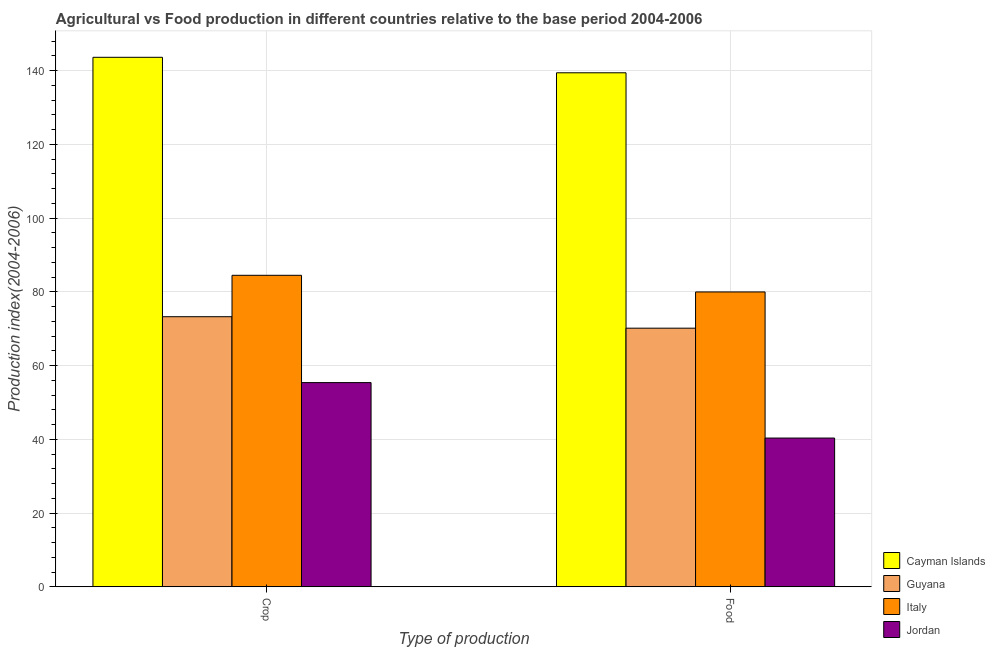How many groups of bars are there?
Ensure brevity in your answer.  2. Are the number of bars per tick equal to the number of legend labels?
Your answer should be compact. Yes. How many bars are there on the 2nd tick from the left?
Give a very brief answer. 4. What is the label of the 2nd group of bars from the left?
Give a very brief answer. Food. What is the food production index in Italy?
Ensure brevity in your answer.  79.96. Across all countries, what is the maximum food production index?
Your response must be concise. 139.4. Across all countries, what is the minimum crop production index?
Give a very brief answer. 55.37. In which country was the food production index maximum?
Your answer should be very brief. Cayman Islands. In which country was the food production index minimum?
Keep it short and to the point. Jordan. What is the total food production index in the graph?
Offer a terse response. 329.82. What is the difference between the food production index in Cayman Islands and that in Guyana?
Give a very brief answer. 69.27. What is the difference between the food production index in Italy and the crop production index in Jordan?
Provide a short and direct response. 24.59. What is the average crop production index per country?
Make the answer very short. 89.17. What is the difference between the food production index and crop production index in Guyana?
Offer a terse response. -3.11. In how many countries, is the food production index greater than 88 ?
Your response must be concise. 1. What is the ratio of the food production index in Italy to that in Cayman Islands?
Keep it short and to the point. 0.57. What does the 2nd bar from the left in Food represents?
Keep it short and to the point. Guyana. What does the 4th bar from the right in Crop represents?
Offer a very short reply. Cayman Islands. Are all the bars in the graph horizontal?
Your answer should be compact. No. Are the values on the major ticks of Y-axis written in scientific E-notation?
Provide a succinct answer. No. Does the graph contain any zero values?
Give a very brief answer. No. What is the title of the graph?
Your answer should be compact. Agricultural vs Food production in different countries relative to the base period 2004-2006. Does "Bahrain" appear as one of the legend labels in the graph?
Keep it short and to the point. No. What is the label or title of the X-axis?
Offer a very short reply. Type of production. What is the label or title of the Y-axis?
Make the answer very short. Production index(2004-2006). What is the Production index(2004-2006) of Cayman Islands in Crop?
Offer a very short reply. 143.6. What is the Production index(2004-2006) of Guyana in Crop?
Give a very brief answer. 73.24. What is the Production index(2004-2006) in Italy in Crop?
Provide a succinct answer. 84.47. What is the Production index(2004-2006) of Jordan in Crop?
Provide a short and direct response. 55.37. What is the Production index(2004-2006) of Cayman Islands in Food?
Provide a succinct answer. 139.4. What is the Production index(2004-2006) in Guyana in Food?
Offer a terse response. 70.13. What is the Production index(2004-2006) in Italy in Food?
Offer a very short reply. 79.96. What is the Production index(2004-2006) of Jordan in Food?
Give a very brief answer. 40.33. Across all Type of production, what is the maximum Production index(2004-2006) of Cayman Islands?
Give a very brief answer. 143.6. Across all Type of production, what is the maximum Production index(2004-2006) of Guyana?
Keep it short and to the point. 73.24. Across all Type of production, what is the maximum Production index(2004-2006) in Italy?
Offer a very short reply. 84.47. Across all Type of production, what is the maximum Production index(2004-2006) in Jordan?
Your response must be concise. 55.37. Across all Type of production, what is the minimum Production index(2004-2006) in Cayman Islands?
Offer a very short reply. 139.4. Across all Type of production, what is the minimum Production index(2004-2006) in Guyana?
Your response must be concise. 70.13. Across all Type of production, what is the minimum Production index(2004-2006) of Italy?
Make the answer very short. 79.96. Across all Type of production, what is the minimum Production index(2004-2006) of Jordan?
Your response must be concise. 40.33. What is the total Production index(2004-2006) in Cayman Islands in the graph?
Give a very brief answer. 283. What is the total Production index(2004-2006) of Guyana in the graph?
Keep it short and to the point. 143.37. What is the total Production index(2004-2006) in Italy in the graph?
Offer a terse response. 164.43. What is the total Production index(2004-2006) of Jordan in the graph?
Your answer should be very brief. 95.7. What is the difference between the Production index(2004-2006) in Guyana in Crop and that in Food?
Offer a very short reply. 3.11. What is the difference between the Production index(2004-2006) of Italy in Crop and that in Food?
Ensure brevity in your answer.  4.51. What is the difference between the Production index(2004-2006) of Jordan in Crop and that in Food?
Give a very brief answer. 15.04. What is the difference between the Production index(2004-2006) of Cayman Islands in Crop and the Production index(2004-2006) of Guyana in Food?
Offer a very short reply. 73.47. What is the difference between the Production index(2004-2006) in Cayman Islands in Crop and the Production index(2004-2006) in Italy in Food?
Your answer should be compact. 63.64. What is the difference between the Production index(2004-2006) of Cayman Islands in Crop and the Production index(2004-2006) of Jordan in Food?
Your answer should be very brief. 103.27. What is the difference between the Production index(2004-2006) in Guyana in Crop and the Production index(2004-2006) in Italy in Food?
Ensure brevity in your answer.  -6.72. What is the difference between the Production index(2004-2006) in Guyana in Crop and the Production index(2004-2006) in Jordan in Food?
Give a very brief answer. 32.91. What is the difference between the Production index(2004-2006) in Italy in Crop and the Production index(2004-2006) in Jordan in Food?
Your answer should be compact. 44.14. What is the average Production index(2004-2006) of Cayman Islands per Type of production?
Your answer should be very brief. 141.5. What is the average Production index(2004-2006) of Guyana per Type of production?
Provide a succinct answer. 71.69. What is the average Production index(2004-2006) in Italy per Type of production?
Give a very brief answer. 82.22. What is the average Production index(2004-2006) of Jordan per Type of production?
Offer a terse response. 47.85. What is the difference between the Production index(2004-2006) of Cayman Islands and Production index(2004-2006) of Guyana in Crop?
Give a very brief answer. 70.36. What is the difference between the Production index(2004-2006) in Cayman Islands and Production index(2004-2006) in Italy in Crop?
Ensure brevity in your answer.  59.13. What is the difference between the Production index(2004-2006) in Cayman Islands and Production index(2004-2006) in Jordan in Crop?
Keep it short and to the point. 88.23. What is the difference between the Production index(2004-2006) in Guyana and Production index(2004-2006) in Italy in Crop?
Give a very brief answer. -11.23. What is the difference between the Production index(2004-2006) in Guyana and Production index(2004-2006) in Jordan in Crop?
Ensure brevity in your answer.  17.87. What is the difference between the Production index(2004-2006) in Italy and Production index(2004-2006) in Jordan in Crop?
Offer a very short reply. 29.1. What is the difference between the Production index(2004-2006) in Cayman Islands and Production index(2004-2006) in Guyana in Food?
Your response must be concise. 69.27. What is the difference between the Production index(2004-2006) of Cayman Islands and Production index(2004-2006) of Italy in Food?
Offer a very short reply. 59.44. What is the difference between the Production index(2004-2006) in Cayman Islands and Production index(2004-2006) in Jordan in Food?
Provide a succinct answer. 99.07. What is the difference between the Production index(2004-2006) of Guyana and Production index(2004-2006) of Italy in Food?
Give a very brief answer. -9.83. What is the difference between the Production index(2004-2006) in Guyana and Production index(2004-2006) in Jordan in Food?
Your answer should be compact. 29.8. What is the difference between the Production index(2004-2006) of Italy and Production index(2004-2006) of Jordan in Food?
Provide a succinct answer. 39.63. What is the ratio of the Production index(2004-2006) in Cayman Islands in Crop to that in Food?
Make the answer very short. 1.03. What is the ratio of the Production index(2004-2006) of Guyana in Crop to that in Food?
Give a very brief answer. 1.04. What is the ratio of the Production index(2004-2006) in Italy in Crop to that in Food?
Give a very brief answer. 1.06. What is the ratio of the Production index(2004-2006) in Jordan in Crop to that in Food?
Your answer should be very brief. 1.37. What is the difference between the highest and the second highest Production index(2004-2006) of Cayman Islands?
Provide a short and direct response. 4.2. What is the difference between the highest and the second highest Production index(2004-2006) in Guyana?
Your answer should be compact. 3.11. What is the difference between the highest and the second highest Production index(2004-2006) of Italy?
Keep it short and to the point. 4.51. What is the difference between the highest and the second highest Production index(2004-2006) of Jordan?
Make the answer very short. 15.04. What is the difference between the highest and the lowest Production index(2004-2006) in Guyana?
Provide a succinct answer. 3.11. What is the difference between the highest and the lowest Production index(2004-2006) in Italy?
Your answer should be very brief. 4.51. What is the difference between the highest and the lowest Production index(2004-2006) in Jordan?
Ensure brevity in your answer.  15.04. 